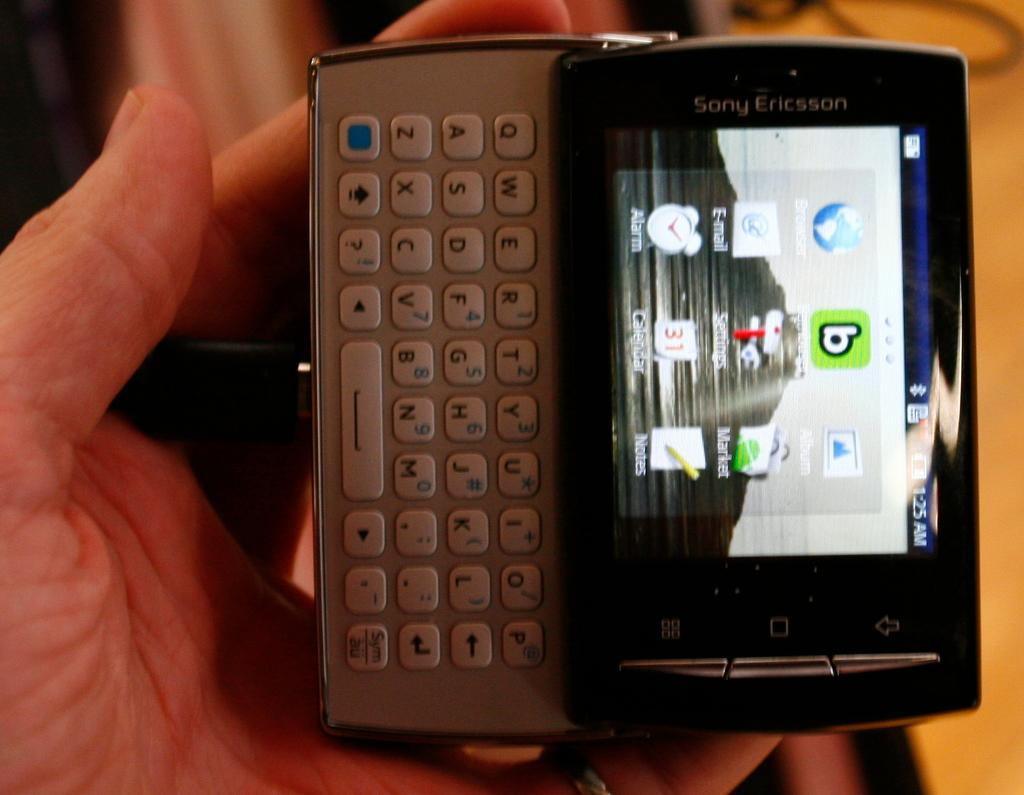<image>
Give a short and clear explanation of the subsequent image. a phone that has the letter b on it 